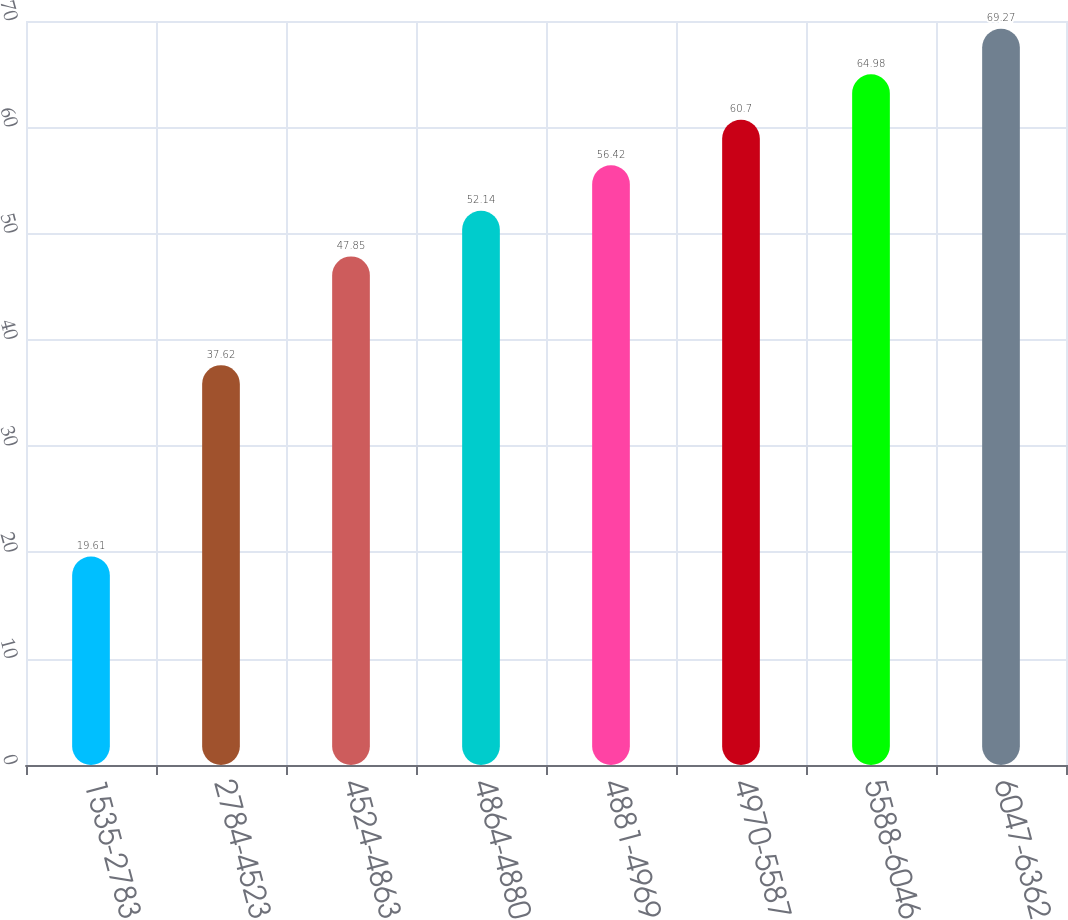<chart> <loc_0><loc_0><loc_500><loc_500><bar_chart><fcel>1535-2783<fcel>2784-4523<fcel>4524-4863<fcel>4864-4880<fcel>4881-4969<fcel>4970-5587<fcel>5588-6046<fcel>6047-6362<nl><fcel>19.61<fcel>37.62<fcel>47.85<fcel>52.14<fcel>56.42<fcel>60.7<fcel>64.98<fcel>69.27<nl></chart> 